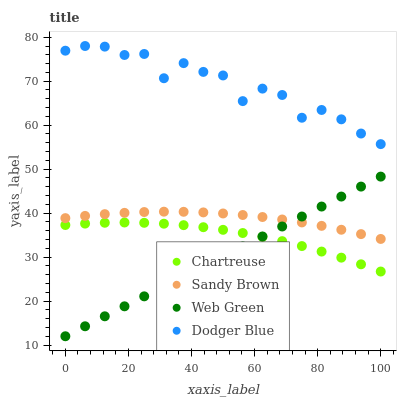Does Web Green have the minimum area under the curve?
Answer yes or no. Yes. Does Dodger Blue have the maximum area under the curve?
Answer yes or no. Yes. Does Chartreuse have the minimum area under the curve?
Answer yes or no. No. Does Chartreuse have the maximum area under the curve?
Answer yes or no. No. Is Web Green the smoothest?
Answer yes or no. Yes. Is Dodger Blue the roughest?
Answer yes or no. Yes. Is Chartreuse the smoothest?
Answer yes or no. No. Is Chartreuse the roughest?
Answer yes or no. No. Does Web Green have the lowest value?
Answer yes or no. Yes. Does Chartreuse have the lowest value?
Answer yes or no. No. Does Dodger Blue have the highest value?
Answer yes or no. Yes. Does Sandy Brown have the highest value?
Answer yes or no. No. Is Web Green less than Dodger Blue?
Answer yes or no. Yes. Is Dodger Blue greater than Sandy Brown?
Answer yes or no. Yes. Does Sandy Brown intersect Web Green?
Answer yes or no. Yes. Is Sandy Brown less than Web Green?
Answer yes or no. No. Is Sandy Brown greater than Web Green?
Answer yes or no. No. Does Web Green intersect Dodger Blue?
Answer yes or no. No. 